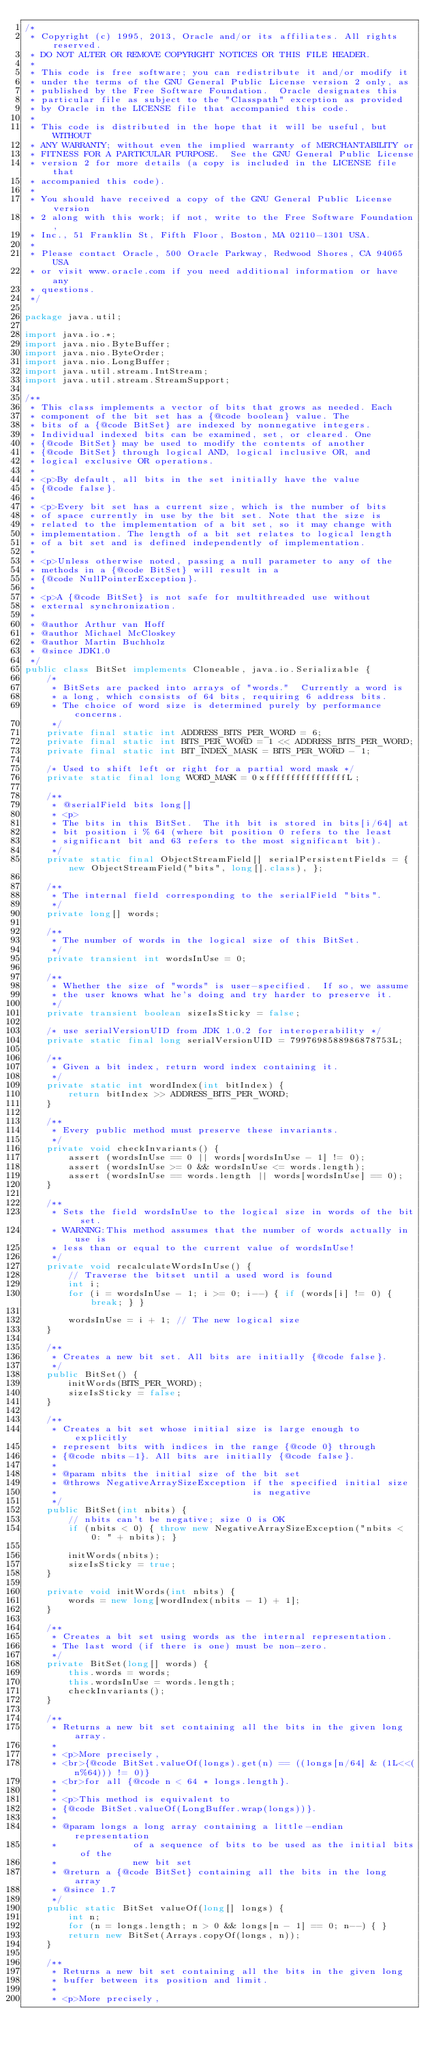<code> <loc_0><loc_0><loc_500><loc_500><_Java_>/*
 * Copyright (c) 1995, 2013, Oracle and/or its affiliates. All rights reserved.
 * DO NOT ALTER OR REMOVE COPYRIGHT NOTICES OR THIS FILE HEADER.
 *
 * This code is free software; you can redistribute it and/or modify it
 * under the terms of the GNU General Public License version 2 only, as
 * published by the Free Software Foundation.  Oracle designates this
 * particular file as subject to the "Classpath" exception as provided
 * by Oracle in the LICENSE file that accompanied this code.
 *
 * This code is distributed in the hope that it will be useful, but WITHOUT
 * ANY WARRANTY; without even the implied warranty of MERCHANTABILITY or
 * FITNESS FOR A PARTICULAR PURPOSE.  See the GNU General Public License
 * version 2 for more details (a copy is included in the LICENSE file that
 * accompanied this code).
 *
 * You should have received a copy of the GNU General Public License version
 * 2 along with this work; if not, write to the Free Software Foundation,
 * Inc., 51 Franklin St, Fifth Floor, Boston, MA 02110-1301 USA.
 *
 * Please contact Oracle, 500 Oracle Parkway, Redwood Shores, CA 94065 USA
 * or visit www.oracle.com if you need additional information or have any
 * questions.
 */

package java.util;

import java.io.*;
import java.nio.ByteBuffer;
import java.nio.ByteOrder;
import java.nio.LongBuffer;
import java.util.stream.IntStream;
import java.util.stream.StreamSupport;

/**
 * This class implements a vector of bits that grows as needed. Each
 * component of the bit set has a {@code boolean} value. The
 * bits of a {@code BitSet} are indexed by nonnegative integers.
 * Individual indexed bits can be examined, set, or cleared. One
 * {@code BitSet} may be used to modify the contents of another
 * {@code BitSet} through logical AND, logical inclusive OR, and
 * logical exclusive OR operations.
 *
 * <p>By default, all bits in the set initially have the value
 * {@code false}.
 *
 * <p>Every bit set has a current size, which is the number of bits
 * of space currently in use by the bit set. Note that the size is
 * related to the implementation of a bit set, so it may change with
 * implementation. The length of a bit set relates to logical length
 * of a bit set and is defined independently of implementation.
 *
 * <p>Unless otherwise noted, passing a null parameter to any of the
 * methods in a {@code BitSet} will result in a
 * {@code NullPointerException}.
 *
 * <p>A {@code BitSet} is not safe for multithreaded use without
 * external synchronization.
 *
 * @author Arthur van Hoff
 * @author Michael McCloskey
 * @author Martin Buchholz
 * @since JDK1.0
 */
public class BitSet implements Cloneable, java.io.Serializable {
    /*
     * BitSets are packed into arrays of "words."  Currently a word is
     * a long, which consists of 64 bits, requiring 6 address bits.
     * The choice of word size is determined purely by performance concerns.
     */
    private final static int ADDRESS_BITS_PER_WORD = 6;
    private final static int BITS_PER_WORD = 1 << ADDRESS_BITS_PER_WORD;
    private final static int BIT_INDEX_MASK = BITS_PER_WORD - 1;

    /* Used to shift left or right for a partial word mask */
    private static final long WORD_MASK = 0xffffffffffffffffL;

    /**
     * @serialField bits long[]
     * <p>
     * The bits in this BitSet.  The ith bit is stored in bits[i/64] at
     * bit position i % 64 (where bit position 0 refers to the least
     * significant bit and 63 refers to the most significant bit).
     */
    private static final ObjectStreamField[] serialPersistentFields = { new ObjectStreamField("bits", long[].class), };

    /**
     * The internal field corresponding to the serialField "bits".
     */
    private long[] words;

    /**
     * The number of words in the logical size of this BitSet.
     */
    private transient int wordsInUse = 0;

    /**
     * Whether the size of "words" is user-specified.  If so, we assume
     * the user knows what he's doing and try harder to preserve it.
     */
    private transient boolean sizeIsSticky = false;

    /* use serialVersionUID from JDK 1.0.2 for interoperability */
    private static final long serialVersionUID = 7997698588986878753L;

    /**
     * Given a bit index, return word index containing it.
     */
    private static int wordIndex(int bitIndex) {
        return bitIndex >> ADDRESS_BITS_PER_WORD;
    }

    /**
     * Every public method must preserve these invariants.
     */
    private void checkInvariants() {
        assert (wordsInUse == 0 || words[wordsInUse - 1] != 0);
        assert (wordsInUse >= 0 && wordsInUse <= words.length);
        assert (wordsInUse == words.length || words[wordsInUse] == 0);
    }

    /**
     * Sets the field wordsInUse to the logical size in words of the bit set.
     * WARNING:This method assumes that the number of words actually in use is
     * less than or equal to the current value of wordsInUse!
     */
    private void recalculateWordsInUse() {
        // Traverse the bitset until a used word is found
        int i;
        for (i = wordsInUse - 1; i >= 0; i--) { if (words[i] != 0) { break; } }

        wordsInUse = i + 1; // The new logical size
    }

    /**
     * Creates a new bit set. All bits are initially {@code false}.
     */
    public BitSet() {
        initWords(BITS_PER_WORD);
        sizeIsSticky = false;
    }

    /**
     * Creates a bit set whose initial size is large enough to explicitly
     * represent bits with indices in the range {@code 0} through
     * {@code nbits-1}. All bits are initially {@code false}.
     *
     * @param nbits the initial size of the bit set
     * @throws NegativeArraySizeException if the specified initial size
     *                                    is negative
     */
    public BitSet(int nbits) {
        // nbits can't be negative; size 0 is OK
        if (nbits < 0) { throw new NegativeArraySizeException("nbits < 0: " + nbits); }

        initWords(nbits);
        sizeIsSticky = true;
    }

    private void initWords(int nbits) {
        words = new long[wordIndex(nbits - 1) + 1];
    }

    /**
     * Creates a bit set using words as the internal representation.
     * The last word (if there is one) must be non-zero.
     */
    private BitSet(long[] words) {
        this.words = words;
        this.wordsInUse = words.length;
        checkInvariants();
    }

    /**
     * Returns a new bit set containing all the bits in the given long array.
     *
     * <p>More precisely,
     * <br>{@code BitSet.valueOf(longs).get(n) == ((longs[n/64] & (1L<<(n%64))) != 0)}
     * <br>for all {@code n < 64 * longs.length}.
     *
     * <p>This method is equivalent to
     * {@code BitSet.valueOf(LongBuffer.wrap(longs))}.
     *
     * @param longs a long array containing a little-endian representation
     *              of a sequence of bits to be used as the initial bits of the
     *              new bit set
     * @return a {@code BitSet} containing all the bits in the long array
     * @since 1.7
     */
    public static BitSet valueOf(long[] longs) {
        int n;
        for (n = longs.length; n > 0 && longs[n - 1] == 0; n--) { }
        return new BitSet(Arrays.copyOf(longs, n));
    }

    /**
     * Returns a new bit set containing all the bits in the given long
     * buffer between its position and limit.
     *
     * <p>More precisely,</code> 